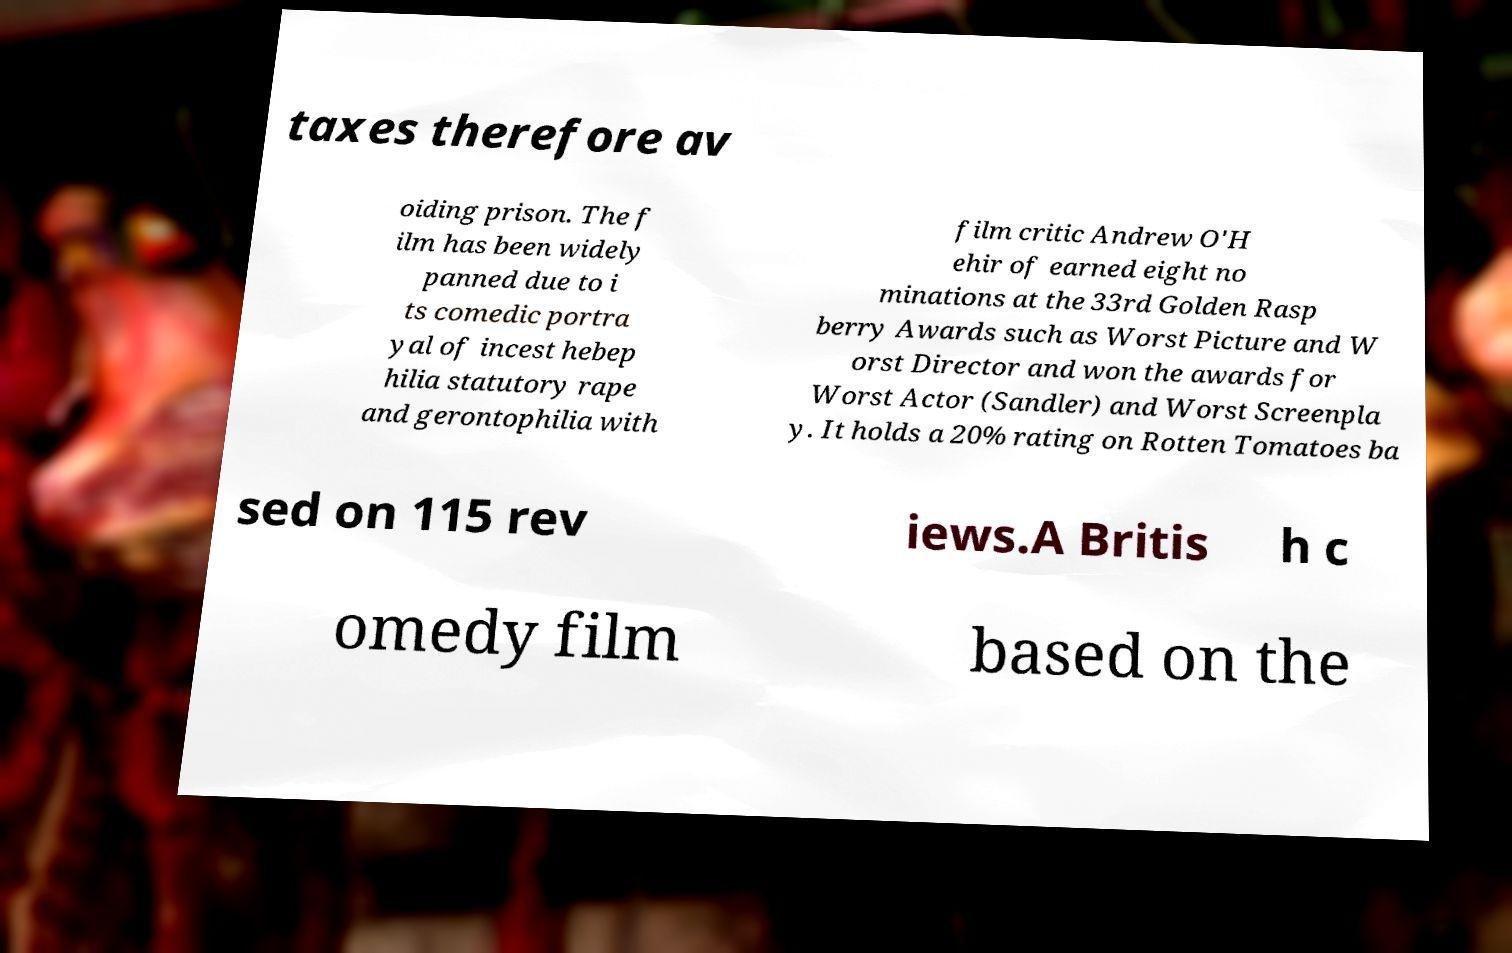Please identify and transcribe the text found in this image. taxes therefore av oiding prison. The f ilm has been widely panned due to i ts comedic portra yal of incest hebep hilia statutory rape and gerontophilia with film critic Andrew O'H ehir of earned eight no minations at the 33rd Golden Rasp berry Awards such as Worst Picture and W orst Director and won the awards for Worst Actor (Sandler) and Worst Screenpla y. It holds a 20% rating on Rotten Tomatoes ba sed on 115 rev iews.A Britis h c omedy film based on the 